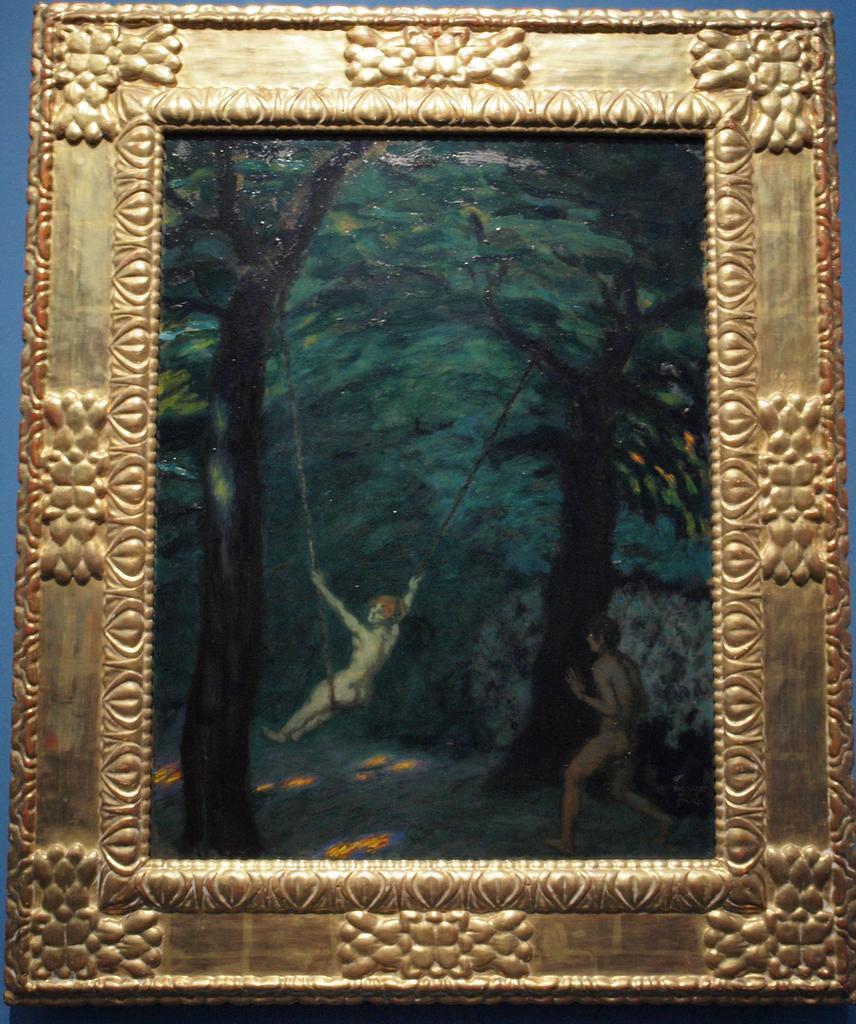In one or two sentences, can you explain what this image depicts? This is a picture of a photo frame with a photo , where there are two persons and there are trees in the photo of the frame. 